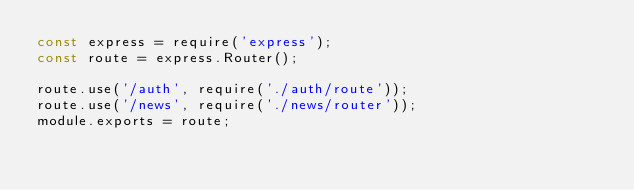Convert code to text. <code><loc_0><loc_0><loc_500><loc_500><_JavaScript_>const express = require('express');
const route = express.Router();

route.use('/auth', require('./auth/route'));
route.use('/news', require('./news/router'));
module.exports = route;</code> 